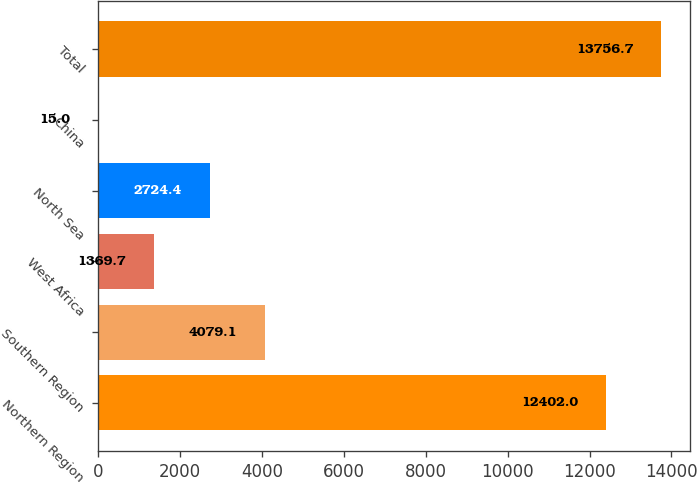Convert chart. <chart><loc_0><loc_0><loc_500><loc_500><bar_chart><fcel>Northern Region<fcel>Southern Region<fcel>West Africa<fcel>North Sea<fcel>China<fcel>Total<nl><fcel>12402<fcel>4079.1<fcel>1369.7<fcel>2724.4<fcel>15<fcel>13756.7<nl></chart> 